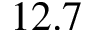Convert formula to latex. <formula><loc_0><loc_0><loc_500><loc_500>1 2 . 7</formula> 